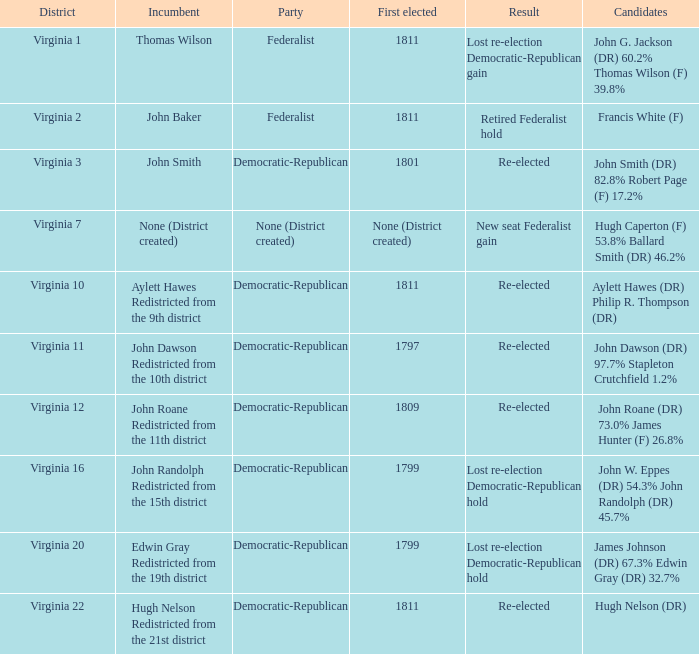Name the distrct for thomas wilson Virginia 1. 